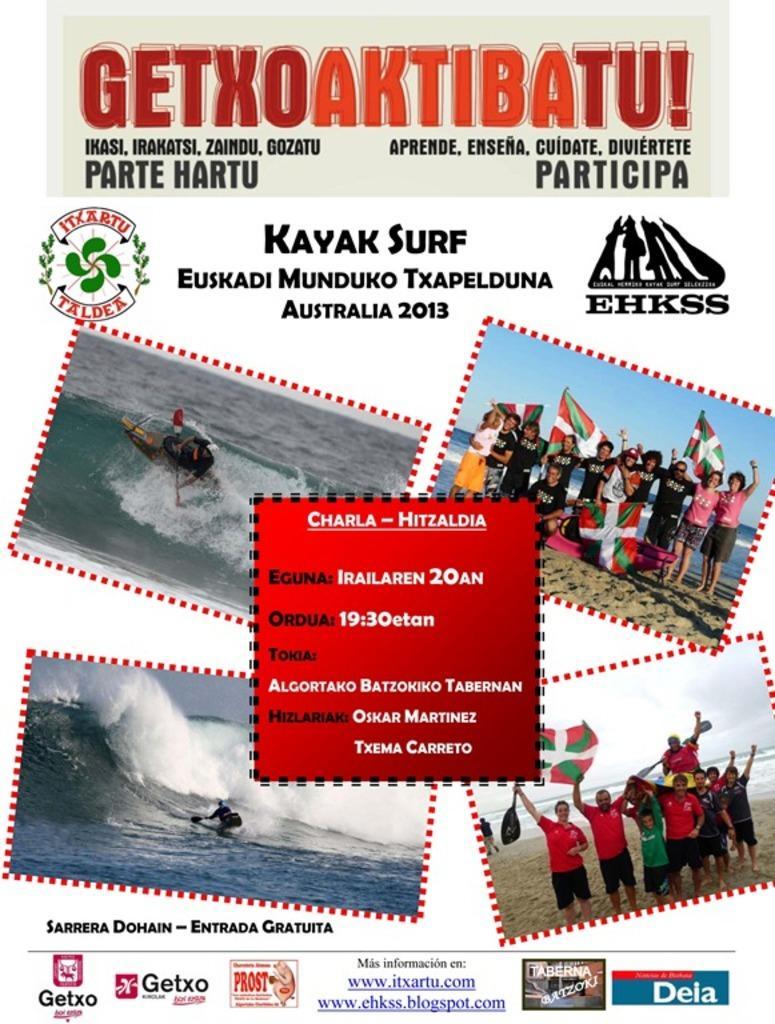How would you summarize this image in a sentence or two? In this image there is a poster with some images and text on it. 